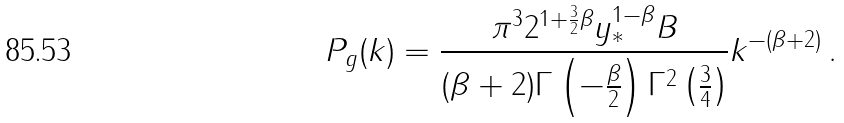Convert formula to latex. <formula><loc_0><loc_0><loc_500><loc_500>P _ { g } ( k ) = \frac { \pi ^ { 3 } 2 ^ { 1 + \frac { 3 } { 2 } \beta } y _ { * } ^ { 1 - \beta } B } { ( \beta + 2 ) \Gamma \left ( - \frac { \beta } { 2 } \right ) \Gamma ^ { 2 } \left ( \frac { 3 } 4 \right ) } k ^ { - ( \beta + 2 ) } \, .</formula> 